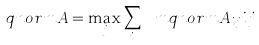<formula> <loc_0><loc_0><loc_500><loc_500>\ q n o r m { A } = \max _ { j } \sum _ { i } \ m q n o r m { A _ { i j } } { i } { j }</formula> 